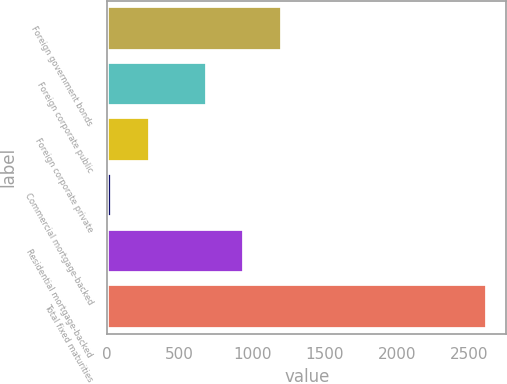Convert chart to OTSL. <chart><loc_0><loc_0><loc_500><loc_500><bar_chart><fcel>Foreign government bonds<fcel>Foreign corporate public<fcel>Foreign corporate private<fcel>Commercial mortgage-backed<fcel>Residential mortgage-backed<fcel>Total fixed maturities<nl><fcel>1205<fcel>687<fcel>293<fcel>34<fcel>946<fcel>2624<nl></chart> 